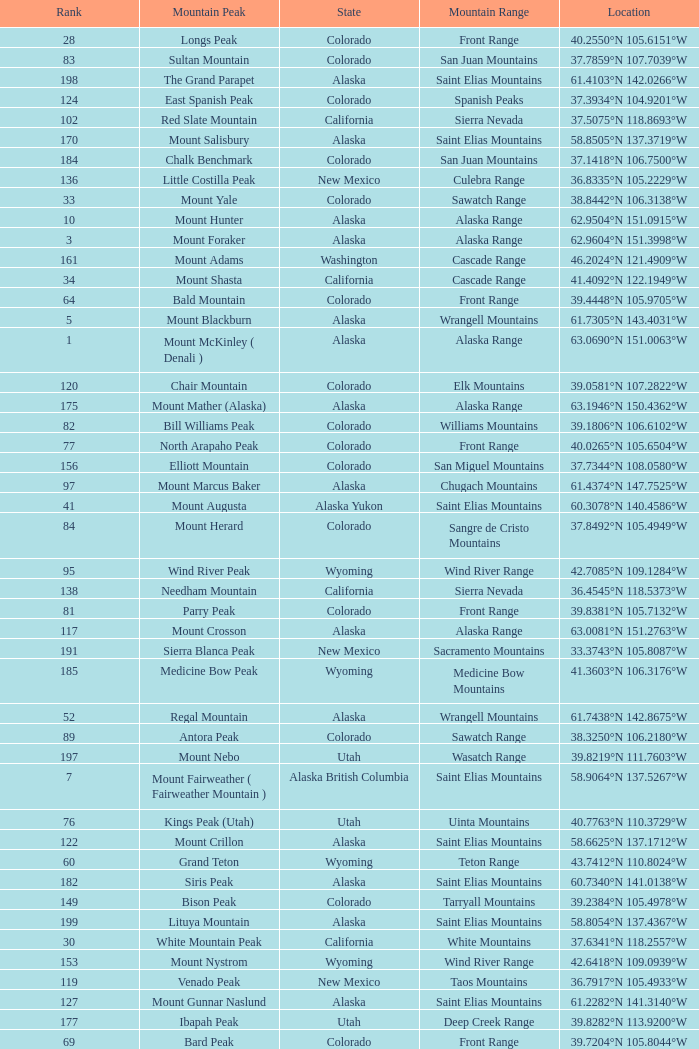What is the mountain peak when the location is 37.5775°n 105.4856°w? Blanca Peak. 